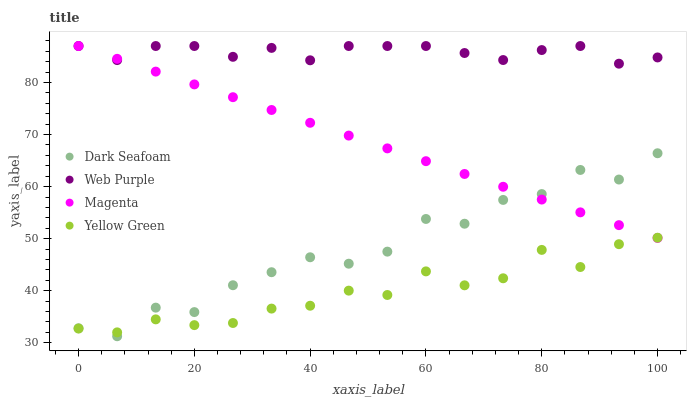Does Yellow Green have the minimum area under the curve?
Answer yes or no. Yes. Does Web Purple have the maximum area under the curve?
Answer yes or no. Yes. Does Magenta have the minimum area under the curve?
Answer yes or no. No. Does Magenta have the maximum area under the curve?
Answer yes or no. No. Is Magenta the smoothest?
Answer yes or no. Yes. Is Dark Seafoam the roughest?
Answer yes or no. Yes. Is Web Purple the smoothest?
Answer yes or no. No. Is Web Purple the roughest?
Answer yes or no. No. Does Dark Seafoam have the lowest value?
Answer yes or no. Yes. Does Magenta have the lowest value?
Answer yes or no. No. Does Magenta have the highest value?
Answer yes or no. Yes. Does Yellow Green have the highest value?
Answer yes or no. No. Is Dark Seafoam less than Web Purple?
Answer yes or no. Yes. Is Web Purple greater than Dark Seafoam?
Answer yes or no. Yes. Does Dark Seafoam intersect Yellow Green?
Answer yes or no. Yes. Is Dark Seafoam less than Yellow Green?
Answer yes or no. No. Is Dark Seafoam greater than Yellow Green?
Answer yes or no. No. Does Dark Seafoam intersect Web Purple?
Answer yes or no. No. 